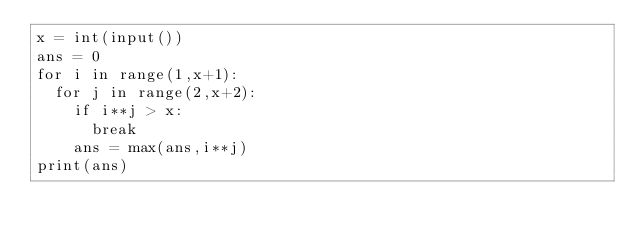<code> <loc_0><loc_0><loc_500><loc_500><_Python_>x = int(input())
ans = 0
for i in range(1,x+1):
  for j in range(2,x+2):
    if i**j > x:
      break
    ans = max(ans,i**j)
print(ans)</code> 